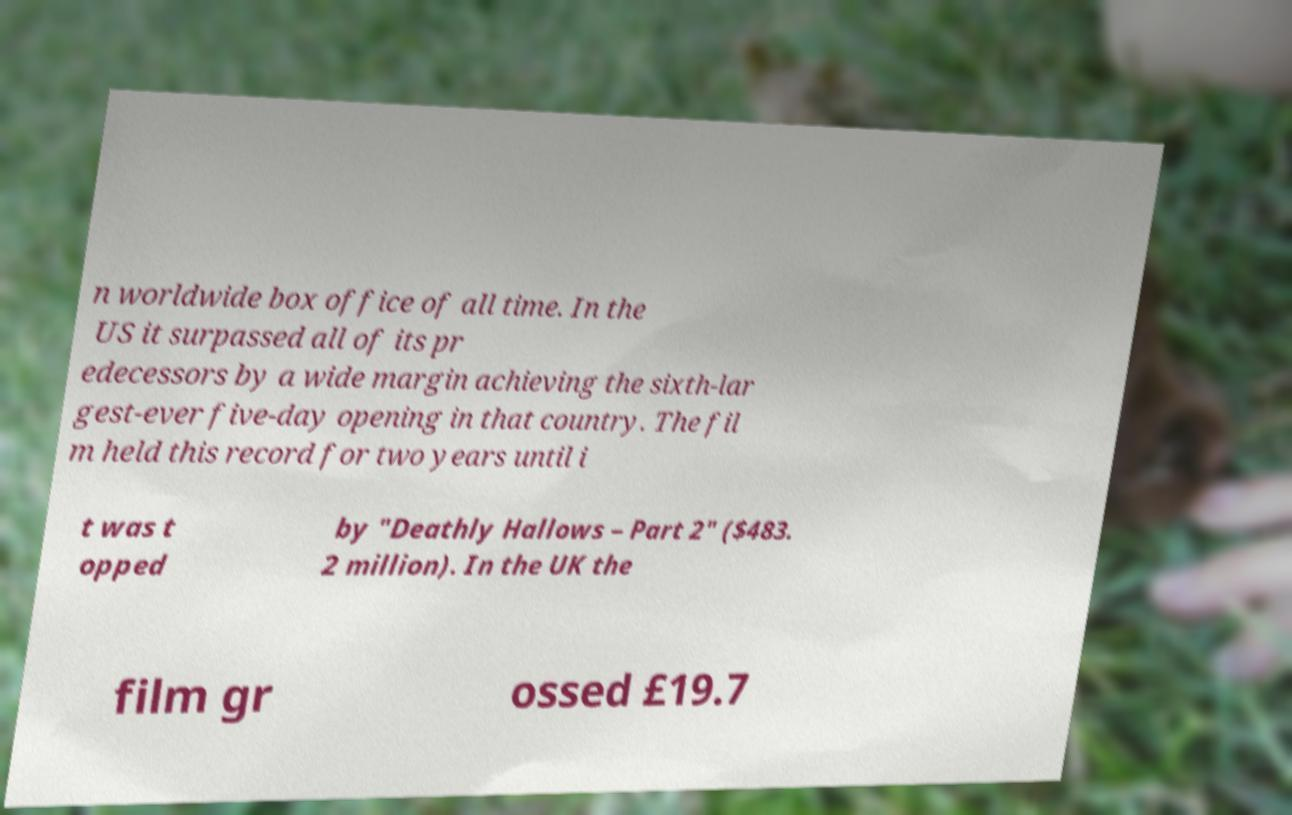Please identify and transcribe the text found in this image. n worldwide box office of all time. In the US it surpassed all of its pr edecessors by a wide margin achieving the sixth-lar gest-ever five-day opening in that country. The fil m held this record for two years until i t was t opped by "Deathly Hallows – Part 2" ($483. 2 million). In the UK the film gr ossed £19.7 